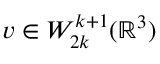<formula> <loc_0><loc_0><loc_500><loc_500>v \in W _ { 2 k } ^ { k + 1 } ( { \mathbb { R } } ^ { 3 } )</formula> 